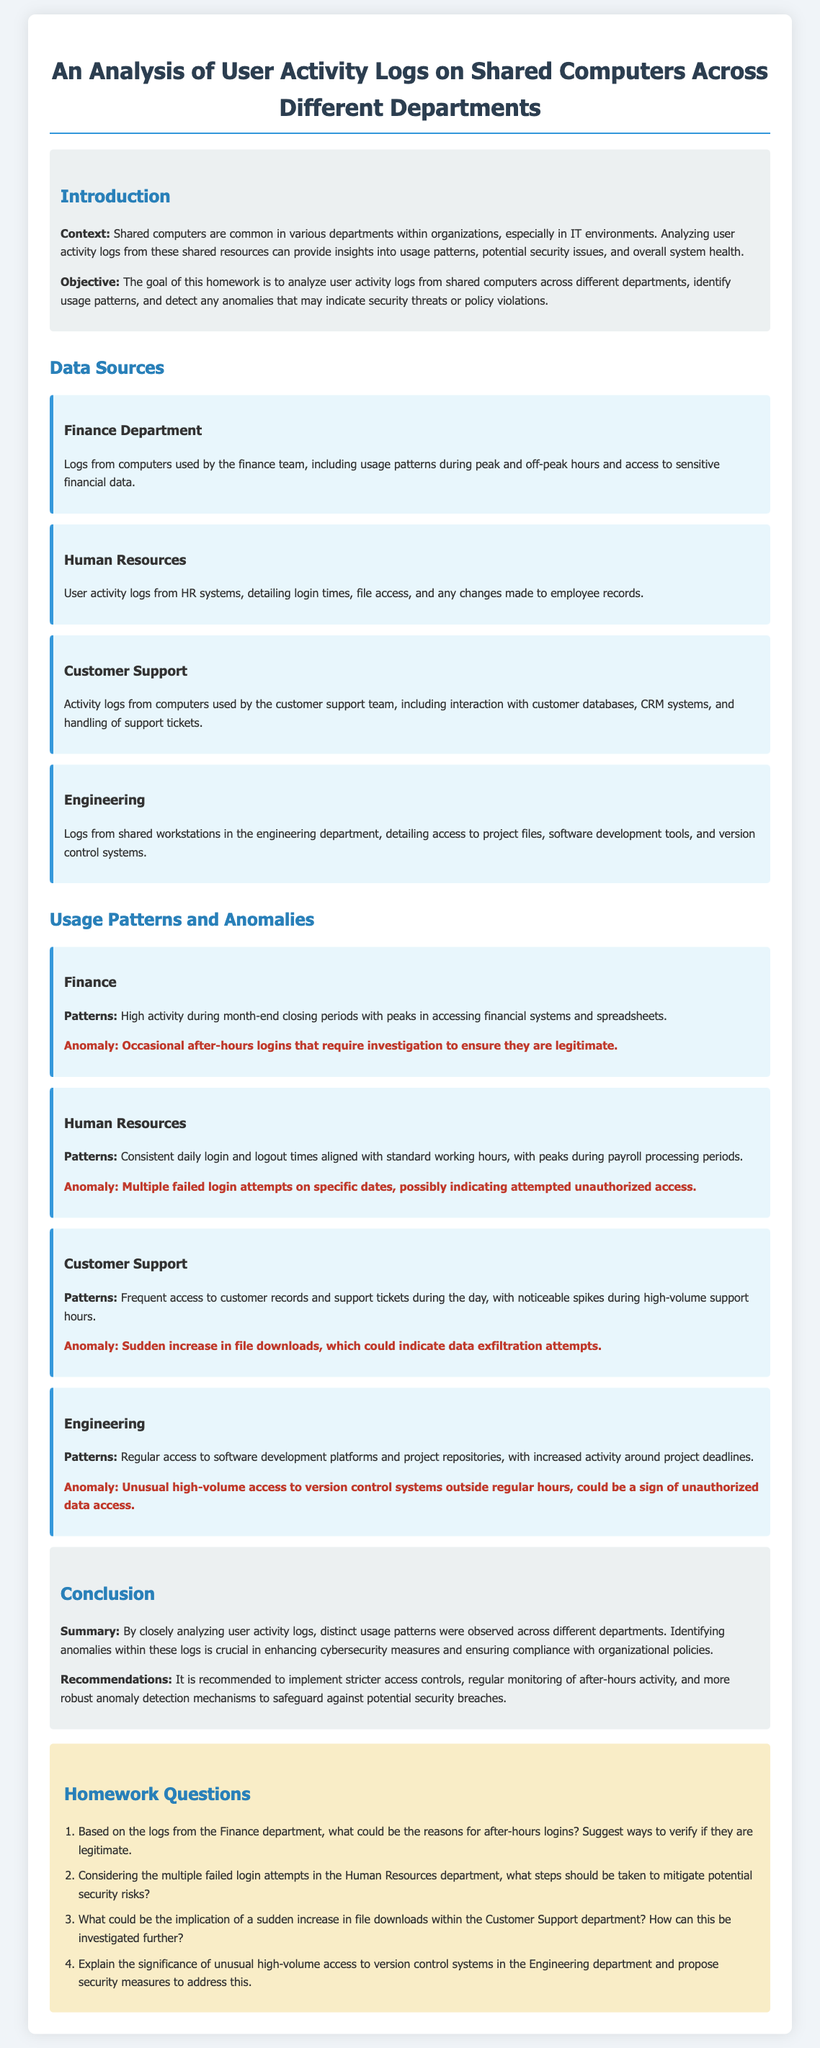What are the peak hours for the Finance department? The document implies that high activity in the Finance department occurs during month-end closing periods, typically associated with specific time frames.
Answer: Month-end closing periods What anomaly is noted in the Human Resources department? The document states there is an anomaly characterized by multiple failed login attempts on specific dates, suggesting a potential security risk.
Answer: Multiple failed login attempts What is the recommendation for handling after-hours logins in the Finance department? The document suggests verifying the legitimacy of after-hours logins to ensure they do not indicate unauthorized access or security breaches.
Answer: Verify legitimacy Which department shows activity spikes during high-volume support hours? The document indicates that the Customer Support department experiences noticeable spikes in activity during high-volume support hours.
Answer: Customer Support What is the implication of unusual access to version control systems in the Engineering department? The document indicates that such access could be a sign of unauthorized data access, highlighting a potential security risk.
Answer: Unauthorized data access How does the document describe usage patterns in the Customer Support department? The document outlines that the Customer Support department frequently accesses customer records and support tickets during the day.
Answer: Frequent access during the day What is the overall objective of the homework? The document states the objective is to analyze user activity logs, identify usage patterns, and detect anomalies.
Answer: Analyze user activity logs What additional measures are recommended for enhancing cybersecurity? The document recommends implementing stricter access controls and regular monitoring of after-hours activity to safeguard against security breaches.
Answer: Stricter access controls What activity pattern is observed in the Engineering department? The document notes that regular access to software development platforms and project repositories is typical, especially around project deadlines.
Answer: Regular access to software development platforms 